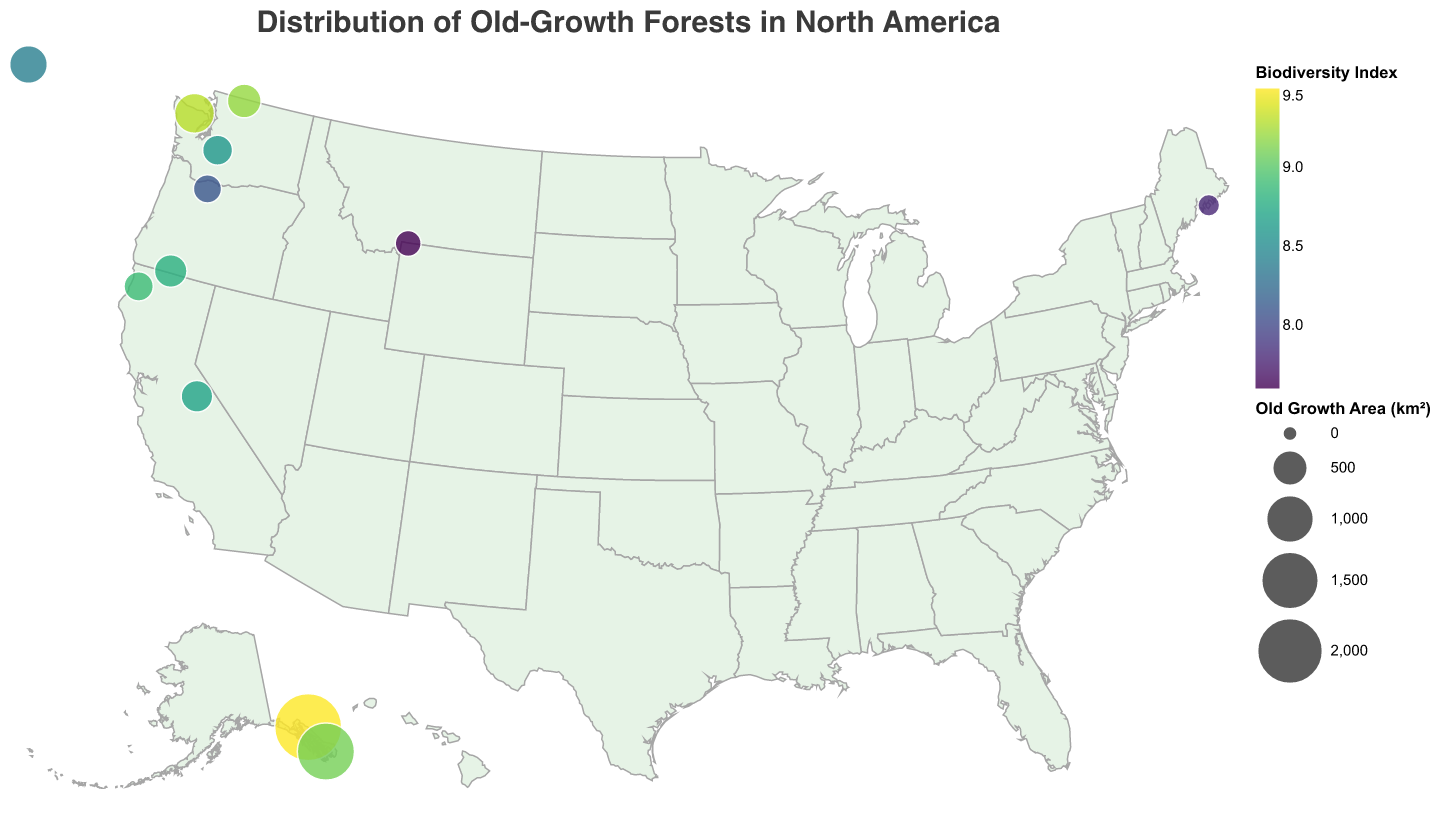What is the title of the figure? The title of the figure is usually displayed at the top in a larger font, and in this plot, it reads "Distribution of Old-Growth Forests in North America".
Answer: Distribution of Old-Growth Forests in North America Which forest has the highest biodiversity index? By examining the color scale, the forest with the highest biodiversity index is represented by the darkest color. Tongass National Forest has the highest biodiversity index of 9.5.
Answer: Tongass National Forest What is the color scheme used to represent the biodiversity index? By looking at the legend, the color scheme used to represent the biodiversity index is a gradient that appears to be in shades of green/yellow/blue. This type of scale is called "viridis".
Answer: viridis How many forests have an old growth area greater than 500 km²? By referring to the size of the circles and the legend representing the old growth area, the forests with circles representing an area greater than 500 km² are Tongass National Forest, Misty Fjords National Monument, Olympic National Park, and Banff National Park.
Answer: 4 Which forest is situated furthest north? The furthest north forest can be found by locating the forest with the highest latitude value. This is Misty Fjords National Monument with a latitude value of 55.6146.
Answer: Misty Fjords National Monument What is the relationship between the size of the old-growth area and the biodiversity index? By observing the figure, examine if larger-sized circles (old-growth area) correspond to higher or lower colors of the color gradient (biodiversity index). The plot shows that generally, larger old-growth areas like Tongass and Misty Fjords have higher biodiversity indices, indicating a positive relationship.
Answer: Positive relationship Which park has the smallest old-growth area, and what is its biodiversity index? By identifying the smallest circles and checking the values in the tooltip, Acadia National Park has the smallest old-growth area with 120 km². Its biodiversity index is 7.8.
Answer: Acadia National Park, 7.8 Compare the biodiversity index of Mount Rainier National Park and Yosemite National Park. By checking the colors in the figure or the tooltip information for these two parks, Mount Rainier National Park has a biodiversity index of 8.6, while Yosemite National Park has a biodiversity index of 8.7.
Answer: Mount Rainier: 8.6, Yosemite: 8.7 What dominant species are found in the forests with the highest old-growth area and highest biodiversity index? By examining the tooltip details for the forest with the highest old-growth area (Tongass National Forest) and the highest biodiversity index (also Tongass National Forest), the dominant species is Sitka Spruce.
Answer: Sitka Spruce 